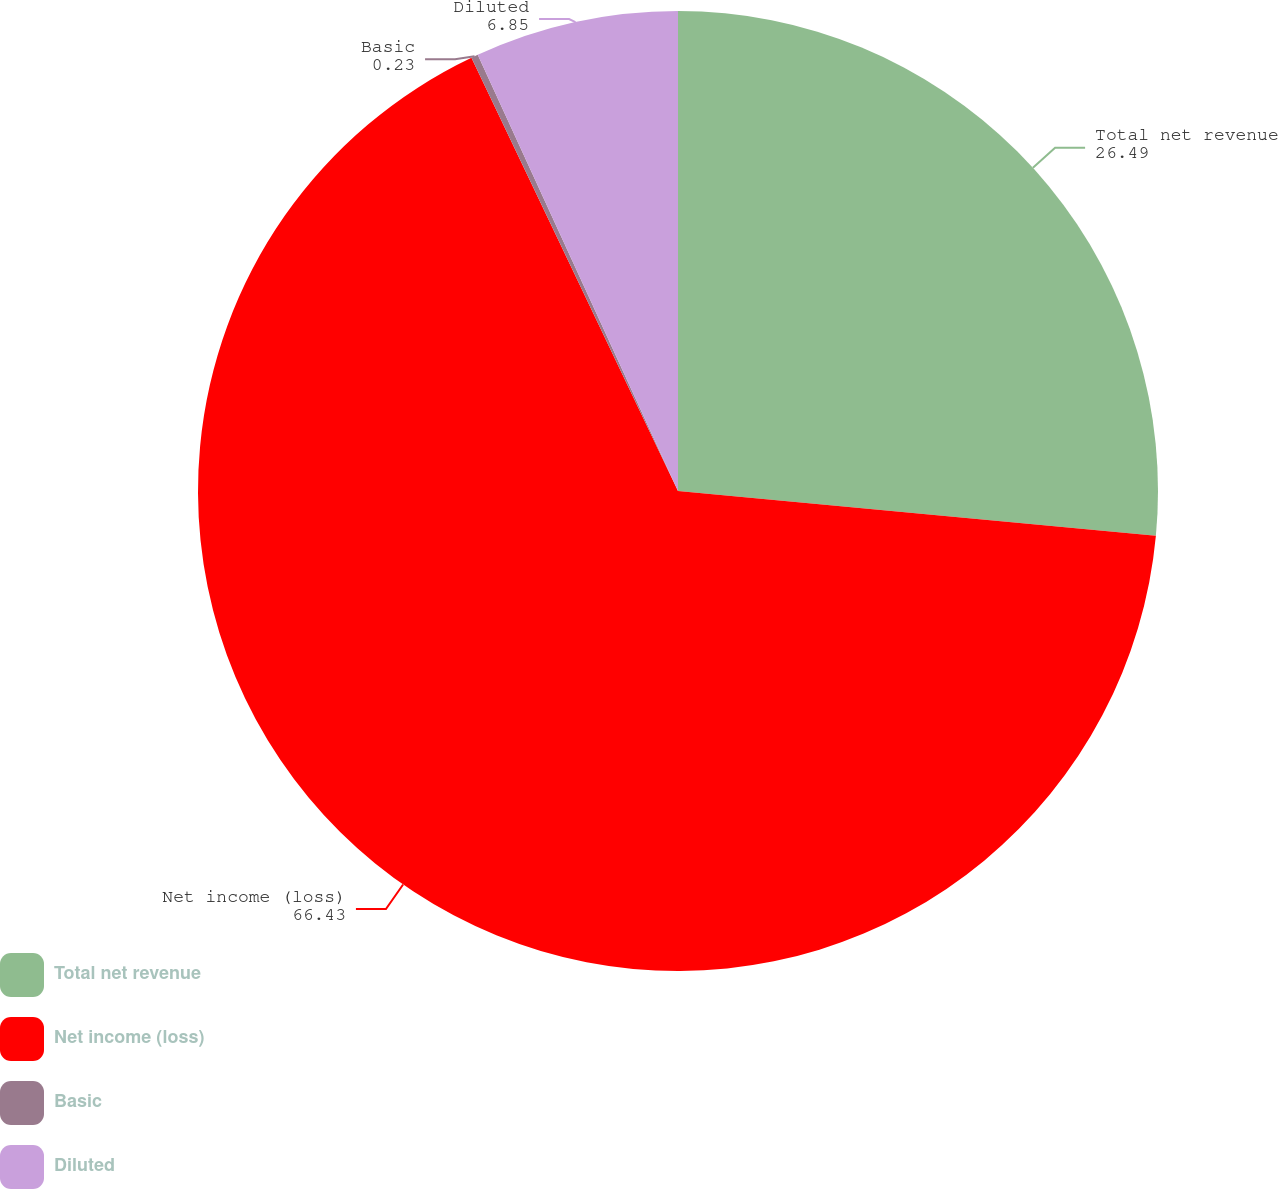<chart> <loc_0><loc_0><loc_500><loc_500><pie_chart><fcel>Total net revenue<fcel>Net income (loss)<fcel>Basic<fcel>Diluted<nl><fcel>26.49%<fcel>66.43%<fcel>0.23%<fcel>6.85%<nl></chart> 